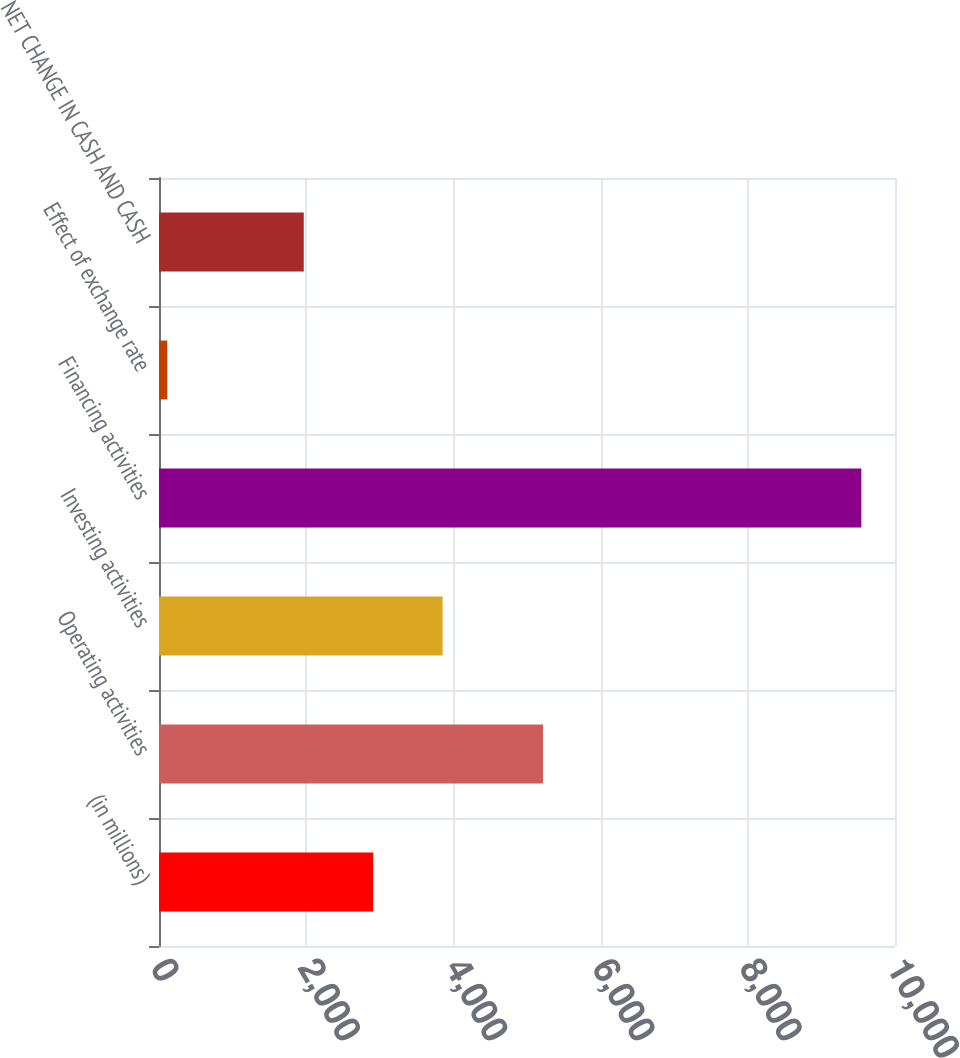Convert chart. <chart><loc_0><loc_0><loc_500><loc_500><bar_chart><fcel>(in millions)<fcel>Operating activities<fcel>Investing activities<fcel>Financing activities<fcel>Effect of exchange rate<fcel>NET CHANGE IN CASH AND CASH<nl><fcel>2910<fcel>5218<fcel>3853<fcel>9543<fcel>113<fcel>1967<nl></chart> 